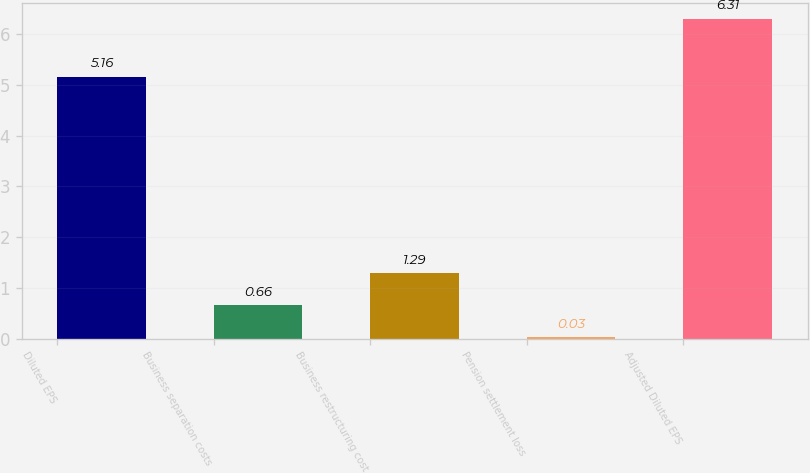Convert chart. <chart><loc_0><loc_0><loc_500><loc_500><bar_chart><fcel>Diluted EPS<fcel>Business separation costs<fcel>Business restructuring cost<fcel>Pension settlement loss<fcel>Adjusted Diluted EPS<nl><fcel>5.16<fcel>0.66<fcel>1.29<fcel>0.03<fcel>6.31<nl></chart> 